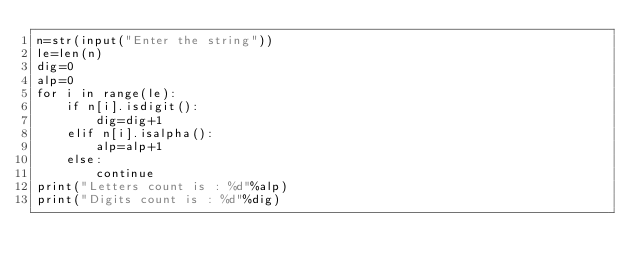<code> <loc_0><loc_0><loc_500><loc_500><_Python_>n=str(input("Enter the string"))
le=len(n)
dig=0
alp=0
for i in range(le):
    if n[i].isdigit():
        dig=dig+1
    elif n[i].isalpha():
        alp=alp+1
    else:
        continue
print("Letters count is : %d"%alp)
print("Digits count is : %d"%dig)
    
        
</code> 